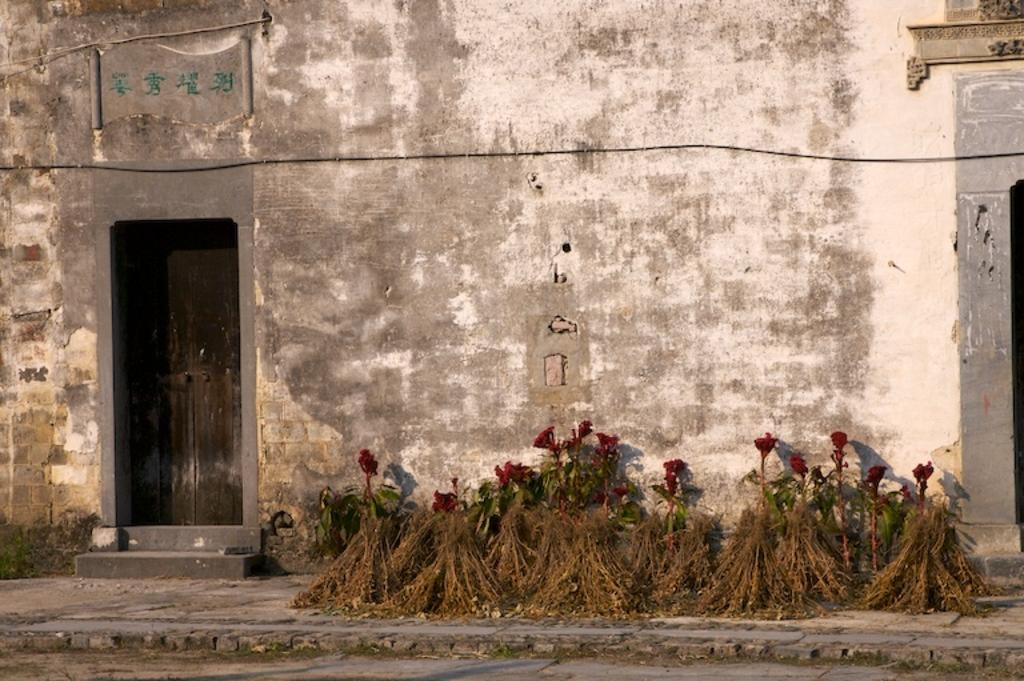What type of flowers can be seen on the road in the image? There are red color flowers on the road in the image. Where is the door located in the image? The door is on the left side of the image. What can be seen in the background of the image? There is a wall in the background of the image. Can you tell me how many hens are sitting on the wall in the image? There are no hens present in the image; it features red color flowers on the road and a door on the left side, with a wall in the background. What type of fowl can be seen flying in the sky in the image? There is no fowl visible in the image; it only shows red color flowers on the road, a door on the left side, and a wall in the background. 